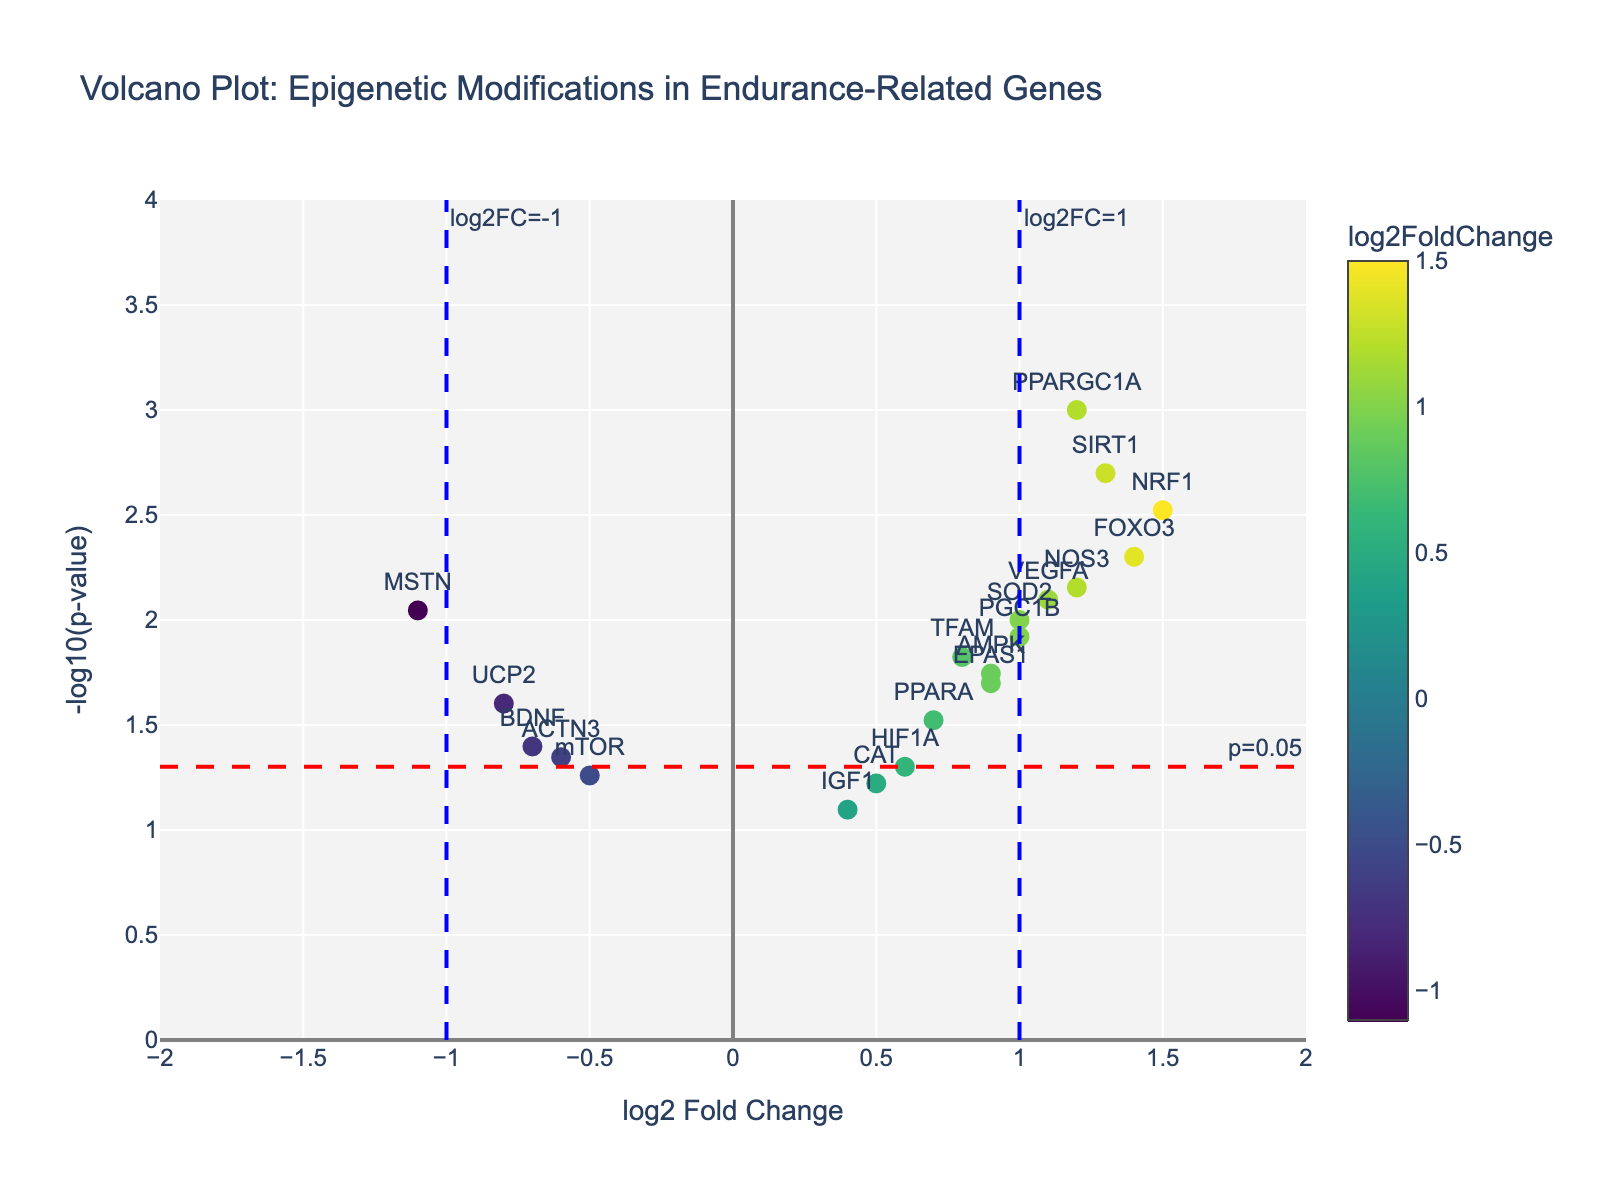What is the title of the Volcano Plot? The title is usually placed at the top of the plot. In this case, the title is "Volcano Plot: Epigenetic Modifications in Endurance-Related Genes".
Answer: Volcano Plot: Epigenetic Modifications in Endurance-Related Genes What are the axes labels of the plot? The x-axis label is "log2 Fold Change" and the y-axis label is "-log10(p-value)", which are typically found near the axes on the plot.
Answer: log2 Fold Change and -log10(p-value) Which gene has the highest log2 Fold Change value? By examining the x-axis (log2 Fold Change), we identify the gene farthest to the right. Here, the gene with the highest log2 Fold Change is NRF1 with a value of 1.5.
Answer: NRF1 How many genes have an absolute log2 Fold Change greater than or equal to 1? First, count the genes to the left of -1 and right of 1 along the x-axis. These are PPARGC1A, NRF1, SIRT1, FOXO3, NOS3, and MSTN.
Answer: 6 genes Which genes have a p-value less than 0.01? The horizontal dashed line at y = 2 (-log10(0.01)) serves as a reference. Genes above this line are PPARGC1A, NRF1, SIRT1, FOXO3, and NOS3.
Answer: PPARGC1A, NRF1, SIRT1, FOXO3, NOS3 What is the position of BDNF on the plot? Locate BDNF based on its log2 Fold Change and -log10(p-value). BDNF has a log2 Fold Change of -0.7 and -log10(p-value) of about 1.4.
Answer: (-0.7, 1.4) Compare the log2 Fold Change values of VEGFA and SOD2. Which is higher? Check the x-axis positions for VEGFA and SOD2. VEGFA has a log2 Fold Change of 1.1 and SOD2 has 1.0, making VEGFA's value higher.
Answer: VEGFA Are there any genes downregulated with a significant p-value (p < 0.05)? Downregulated genes will have negative log2 Fold Change, and significant genes fall above the horizontal dashed line at y = 1.3 (-log10(0.05)). UCP2 and MSTN fit this criterion.
Answer: UCP2, MSTN What does the blue dashed line at x=1 indicate? The blue dashed line at x=1 represents a threshold log2 Fold Change value, marking genes with a log2 Fold Change ≥ 1.
Answer: Log2 Fold Change threshold of 1 Which gene is closest to the log2 Fold Change of 0? The gene closest to the y-axis (log2 Fold Change of 0) appears to be IGF1 with a log2 Fold Change of 0.4.
Answer: IGF1 